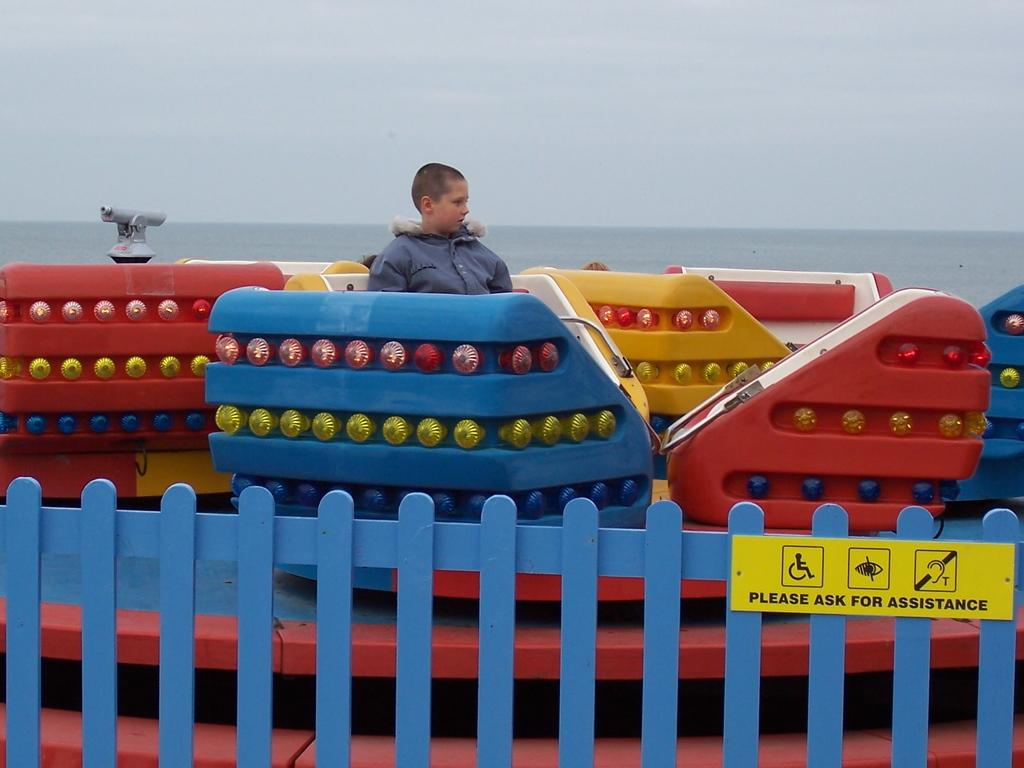What type of structure can be seen in the image? There is a fence in the image. What is located near the fence? There is a boat in the image. Who is on the boat? A boy is sitting on the boat. What can be seen in the background of the image? There is water and the sky visible in the background of the image. Where is the chicken located in the image? There is no chicken present in the image. What type of police vehicle can be seen in the image? There is no police vehicle present in the image. 